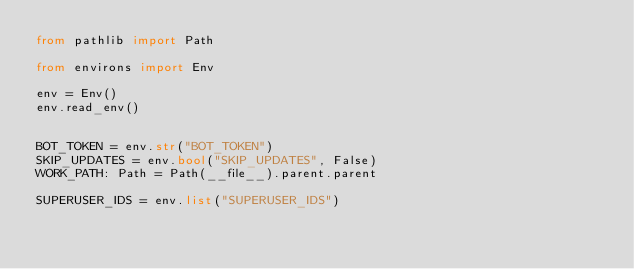<code> <loc_0><loc_0><loc_500><loc_500><_Python_>from pathlib import Path

from environs import Env

env = Env()
env.read_env()


BOT_TOKEN = env.str("BOT_TOKEN")
SKIP_UPDATES = env.bool("SKIP_UPDATES", False)
WORK_PATH: Path = Path(__file__).parent.parent

SUPERUSER_IDS = env.list("SUPERUSER_IDS")
</code> 